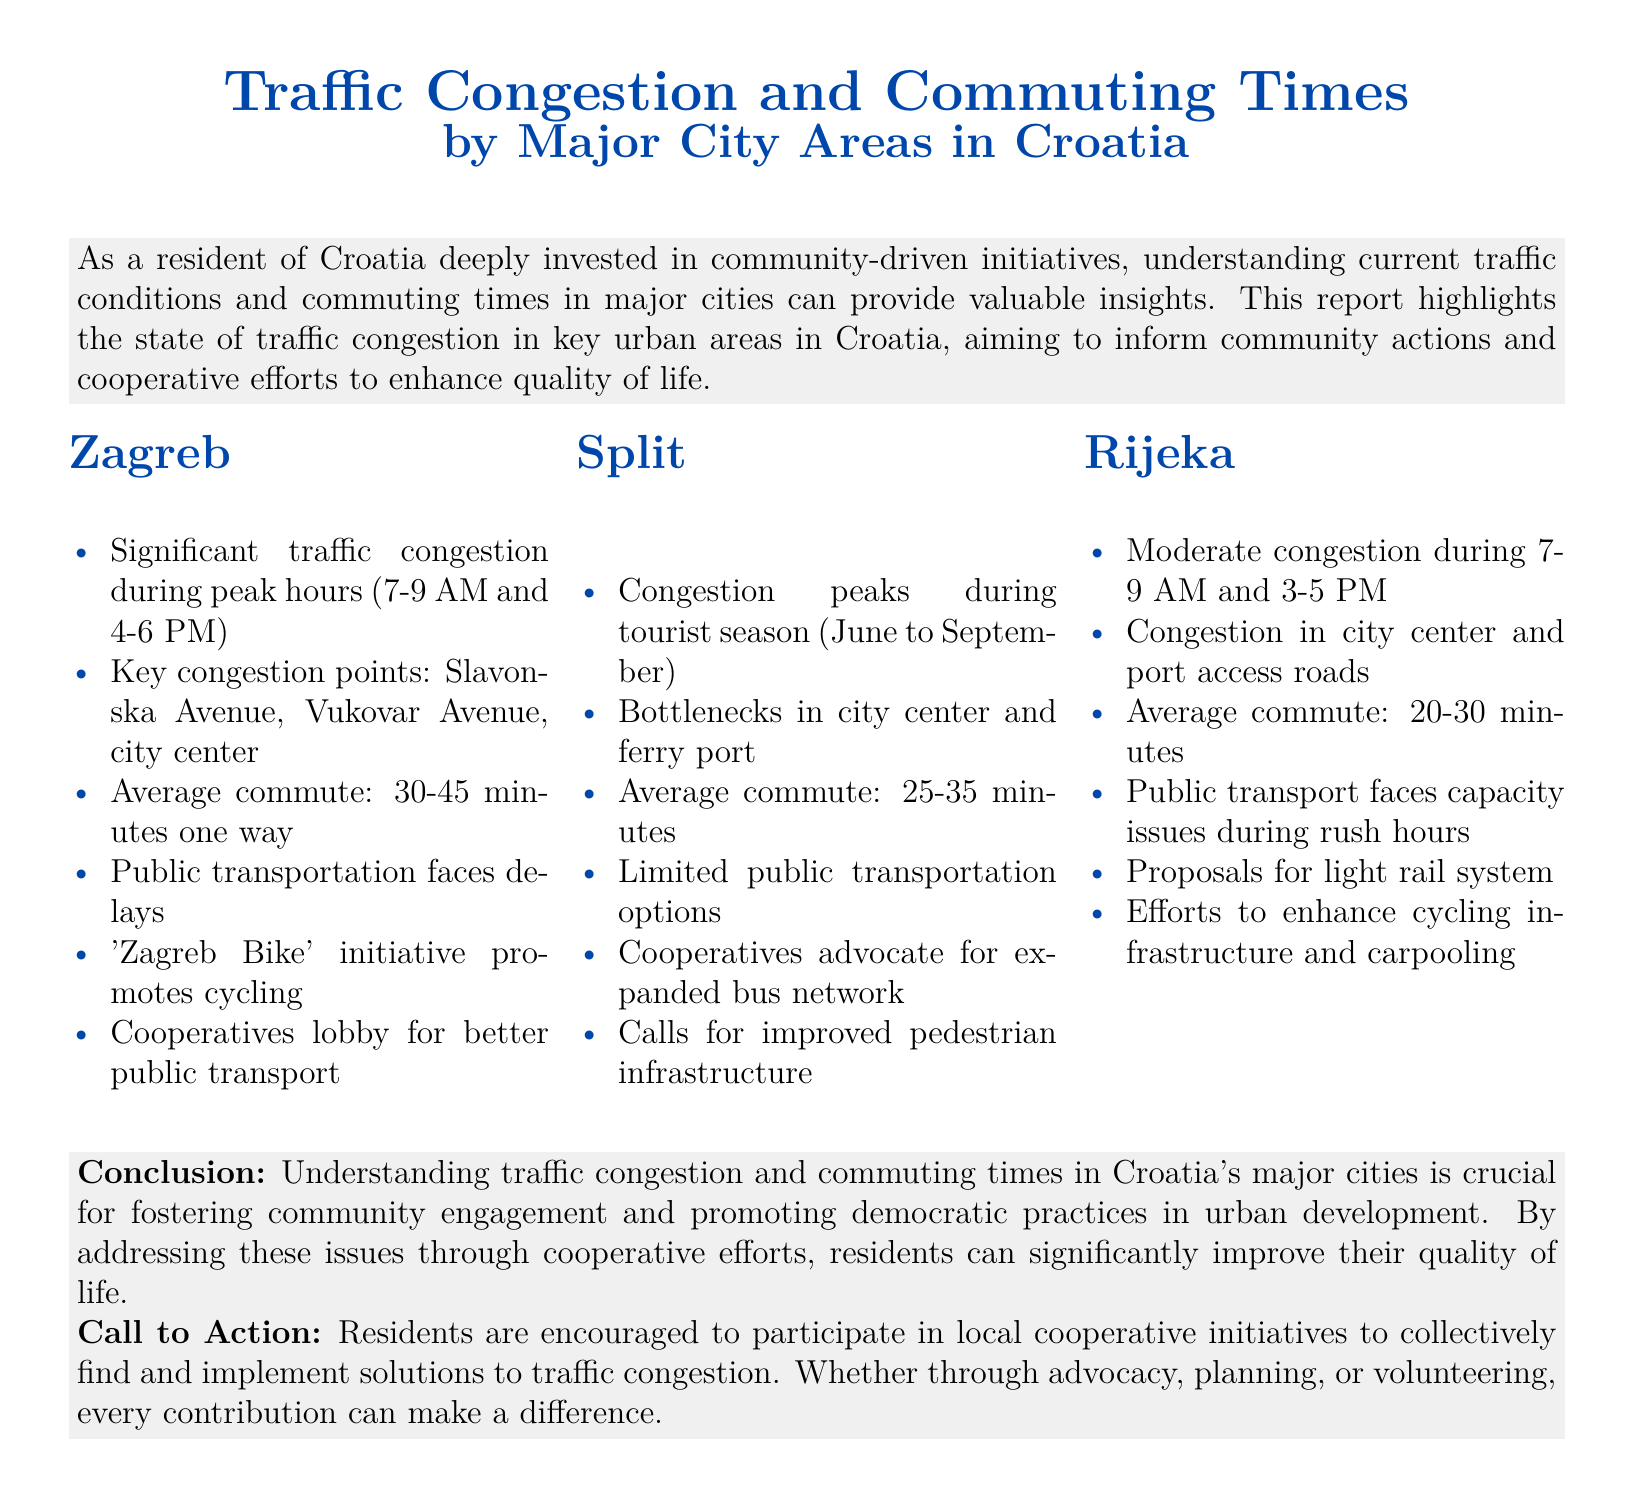What are the peak hours for traffic congestion in Zagreb? The document specifies that significant traffic congestion occurs during the hours of 7-9 AM and 4-6 PM in Zagreb.
Answer: 7-9 AM and 4-6 PM What is the average commute time inSplit? According to the report, the average commute time in Split is between 25-35 minutes one way.
Answer: 25-35 minutes What initiative is promoting cycling in Zagreb? The 'Zagreb Bike' initiative is mentioned as a program that promotes cycling in Zagreb.
Answer: 'Zagreb Bike' What are the bottlenecks in Split? The report identifies the city center and ferry port as the key bottlenecks in Split.
Answer: city center and ferry port How long is the average commute in Rijeka? The average commute time in Rijeka is noted as 20-30 minutes.
Answer: 20-30 minutes What does the report suggest for public transportation in Rijeka? The document mentions proposals for a light rail system to improve public transportation in Rijeka.
Answer: light rail system What community actions are suggested in the conclusion? The conclusion encourages residents to participate in local cooperative initiatives to address traffic congestion.
Answer: participate in local cooperative initiatives What is a key issue faced by public transportation in Rijeka? The report notes that public transport in Rijeka faces capacity issues during rush hours.
Answer: capacity issues What organization advocates for an expanded bus network in Split? The report states that cooperatives advocate for an expanded bus network in Split.
Answer: cooperatives 